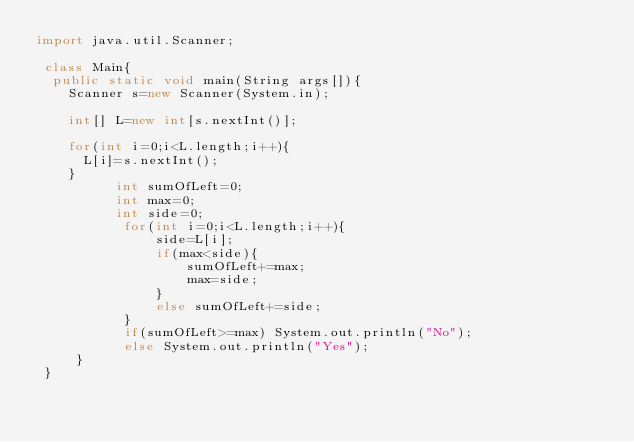Convert code to text. <code><loc_0><loc_0><loc_500><loc_500><_Java_>import java.util.Scanner;

 class Main{
	public static void main(String args[]){
		Scanner s=new Scanner(System.in);

		int[] L=new int[s.nextInt()];

		for(int i=0;i<L.length;i++){
			L[i]=s.nextInt();
		}
	        int sumOfLeft=0;
        	int max=0;
	        int side=0;
        	 for(int i=0;i<L.length;i++){
	             side=L[i];
        	     if(max<side){
                	 sumOfLeft+=max;
	                 max=side;
        	     }
	             else sumOfLeft+=side;
        	 }
	         if(sumOfLeft>=max) System.out.println("No");
        	 else System.out.println("Yes");
     }
 }
</code> 